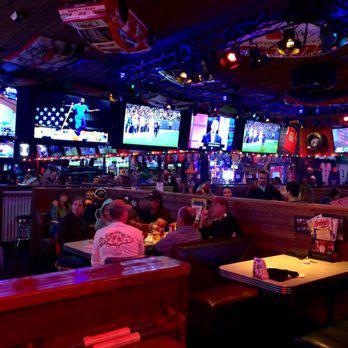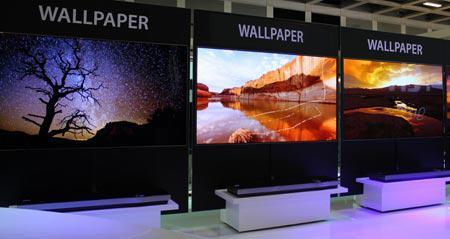The first image is the image on the left, the second image is the image on the right. Analyze the images presented: Is the assertion "One image depicts one or more televisions in a sports bar." valid? Answer yes or no. Yes. The first image is the image on the left, the second image is the image on the right. Assess this claim about the two images: "Chairs are available for people to view the screens in at least one of the images.". Correct or not? Answer yes or no. Yes. 